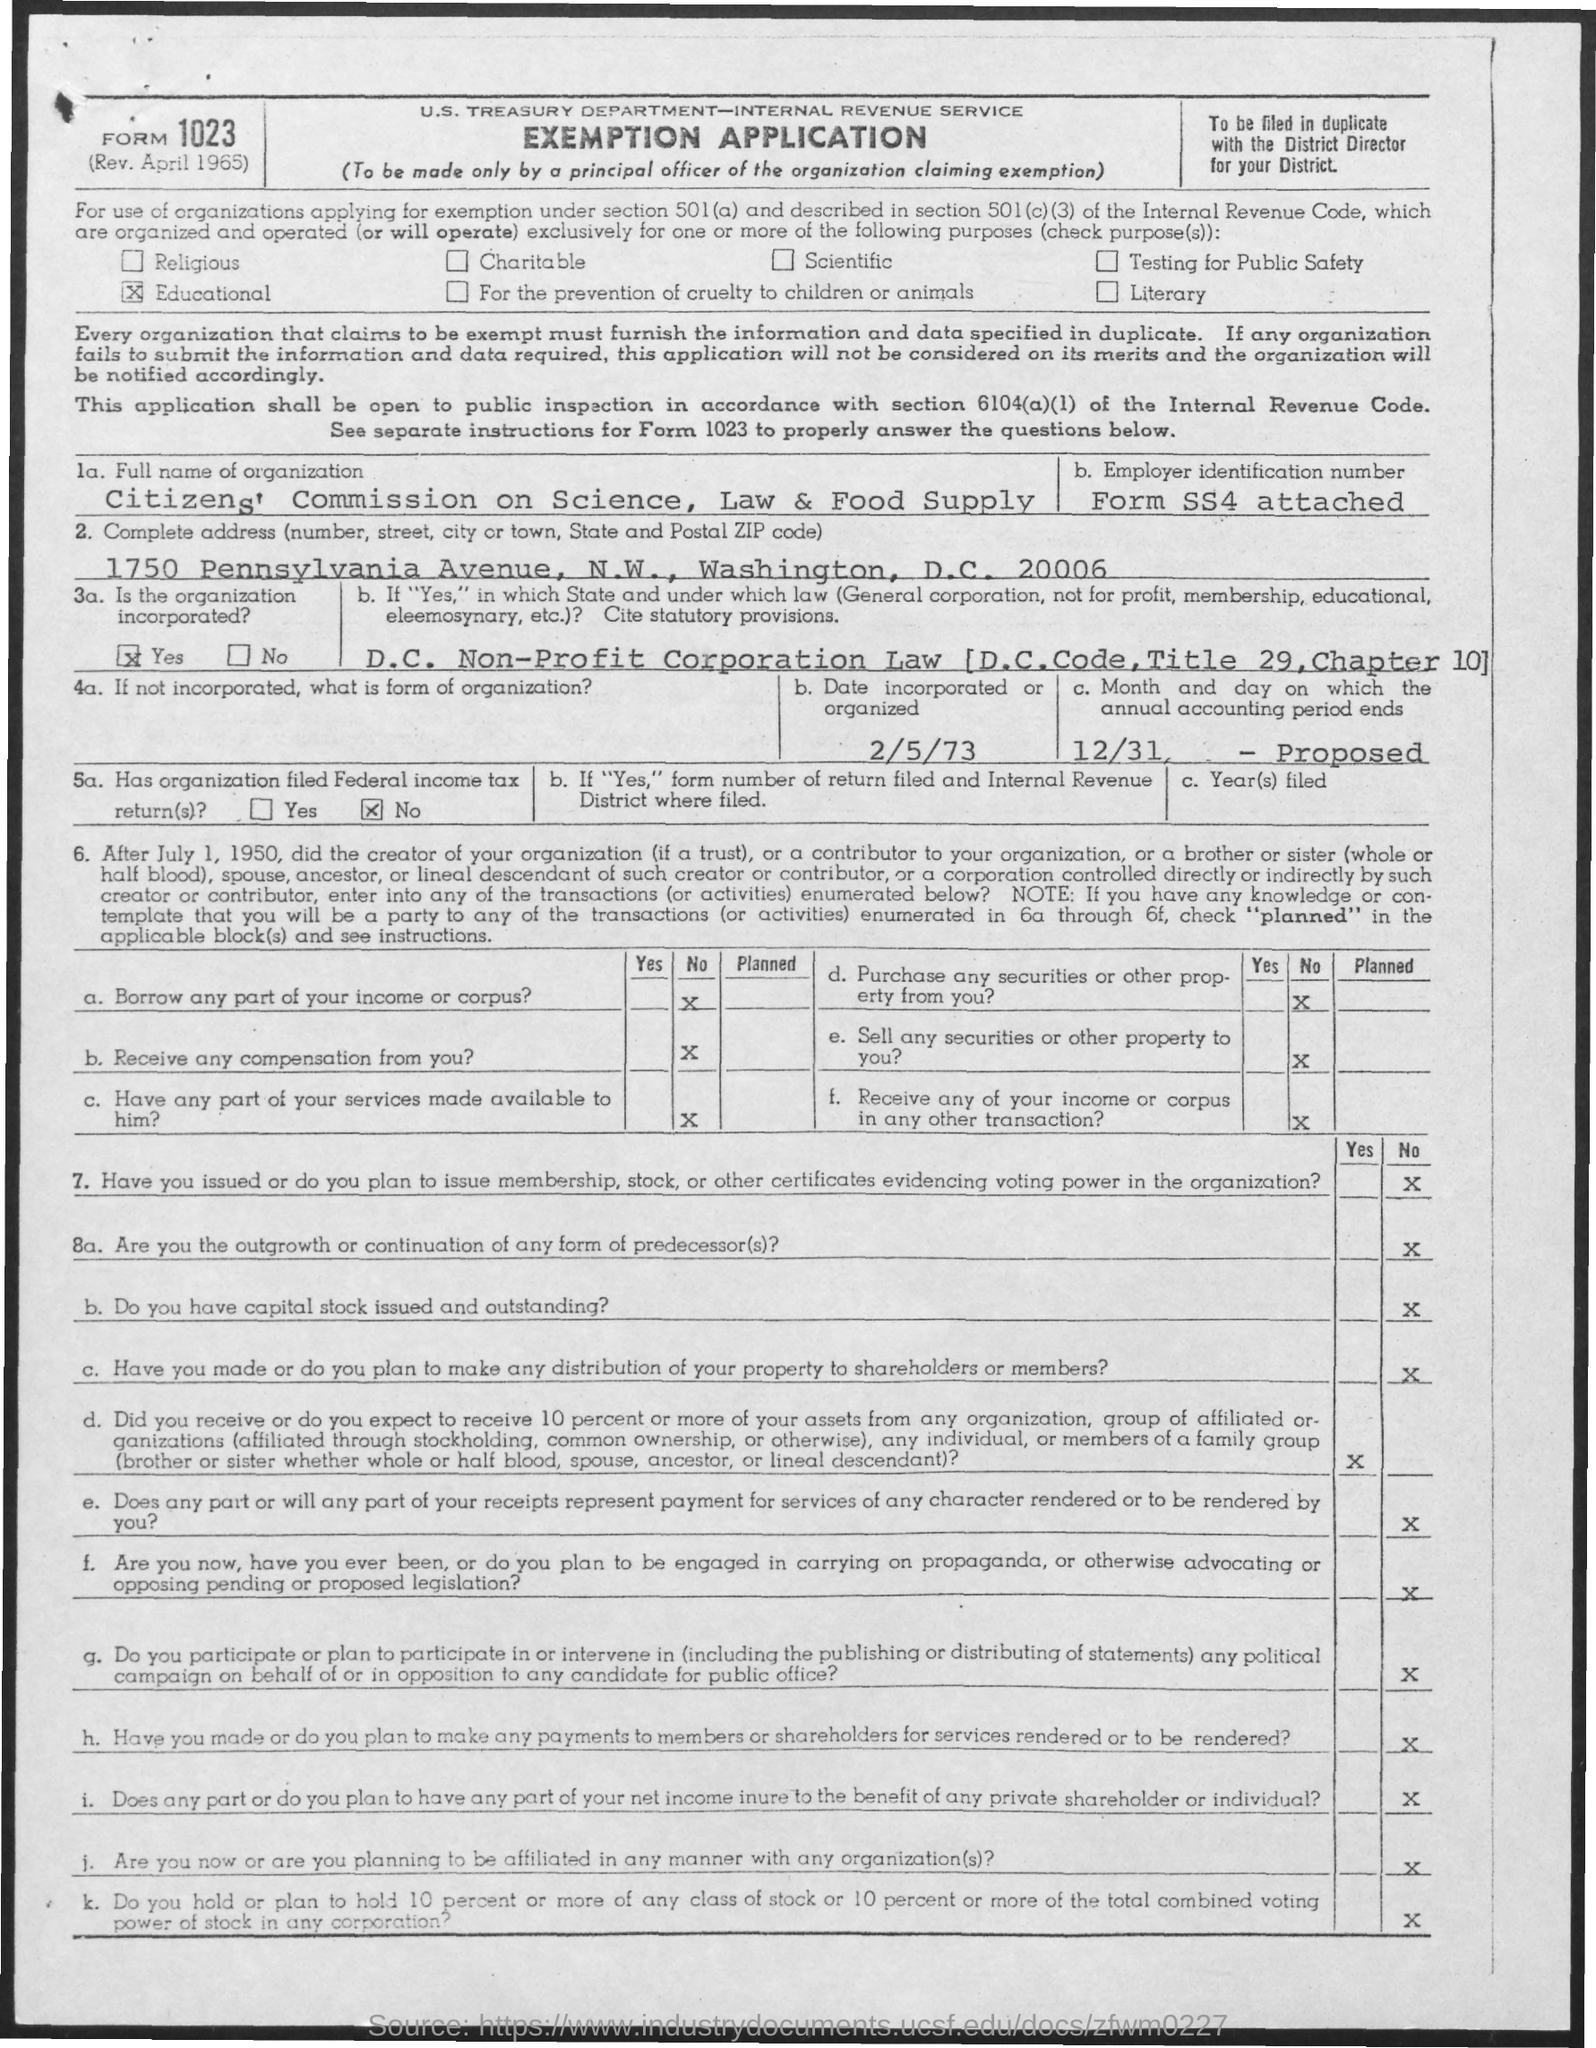Mention a couple of crucial points in this snapshot. The date incorporated or organized, as stated in the application, is 2/5/73. The organization has not filed any Federal income tax returns. The organization listed in the application is called the Citizens' Commission on Science, Law & Food Supply. 